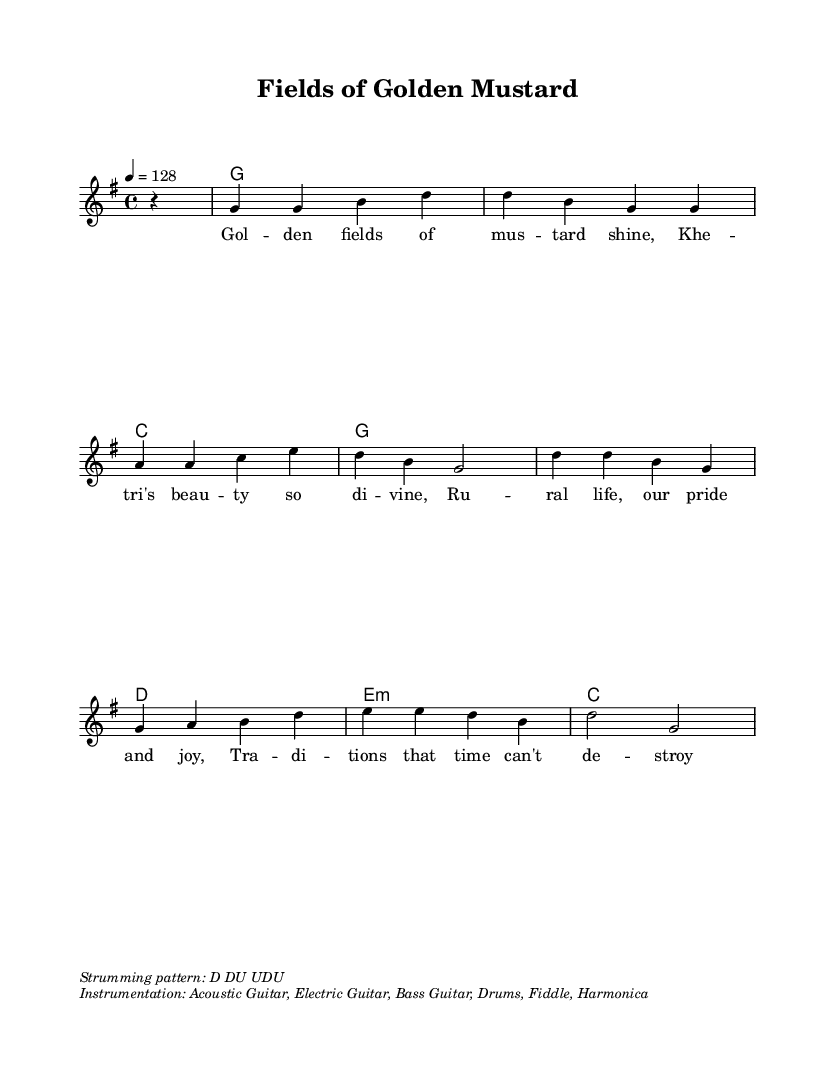What is the key signature of this music? The key signature is G major, which has one sharp (F#). This can be identified at the beginning of the piece where the key signature is indicated.
Answer: G major What is the time signature for this piece? The time signature is 4/4, which means there are four beats in each measure and the quarter note gets one beat. This is marked at the beginning of the sheet music.
Answer: 4/4 What is the tempo marking for this composition? The tempo marking is 128 beats per minute, indicated as "4 = 128." This means the quarter note should be played at a speed of 128 beats per minute.
Answer: 128 How many measures are there in the melody? To find the total number of measures, count the number of times a vertical line (bar line) appears in the melody section. There are nine measures in the provided melody.
Answer: 9 What strumming pattern is suggested for this piece? The strumming pattern is indicated in the markup section as "D DU UDU." This denotes the sequence of down and up strums to be used while playing.
Answer: D DU UDU How many chords are used in the harmony section? The harmony section shows a total of seven different chords in the chord mode. This can be determined by counting the unique chord symbols listed in the section.
Answer: 7 What traditional themes are mentioned in the lyrics? The lyrics emphasize themes of rural life and traditions, celebrating the beauty of life in Khetri and the enduring nature of these traditions over time. This is seen in phrases like "Rural life, our pride and joy."
Answer: Rural life and traditions 